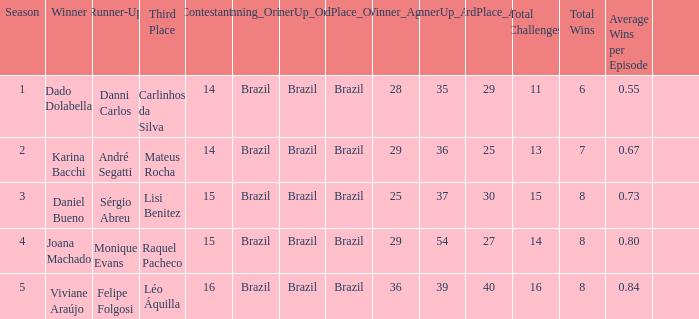How many contestants were there when the runner-up was Sérgio Abreu?  15.0. I'm looking to parse the entire table for insights. Could you assist me with that? {'header': ['Season', 'Winner', 'Runner-Up', 'Third Place', 'Contestants', 'Winning_Origin', 'RunnerUp_Origin', 'ThirdPlace_Origin', 'Winner_Age', 'RunnerUp_Age', 'ThirdPlace_Age', 'Total Challenges', 'Total Wins', 'Average Wins per Episode', ''], 'rows': [['1', 'Dado Dolabella', 'Danni Carlos', 'Carlinhos da Silva', '14', 'Brazil', 'Brazil', 'Brazil', '28', '35', '29', '11', '6', '0.55', ''], ['2', 'Karina Bacchi', 'André Segatti', 'Mateus Rocha', '14', 'Brazil', 'Brazil', 'Brazil', '29', '36', '25', '13', '7', '0.67', ''], ['3', 'Daniel Bueno', 'Sérgio Abreu', 'Lisi Benitez', '15', 'Brazil', 'Brazil', 'Brazil', '25', '37', '30', '15', '8', '0.73', ''], ['4', 'Joana Machado', 'Monique Evans', 'Raquel Pacheco', '15', 'Brazil', 'Brazil', 'Brazil', '29', '54', '27', '14', '8', '0.80', ''], ['5', 'Viviane Araújo', 'Felipe Folgosi', 'Léo Áquilla', '16', 'Brazil', 'Brazil', 'Brazil', '36', '39', '40', '16', '8', '0.84', '']]} 